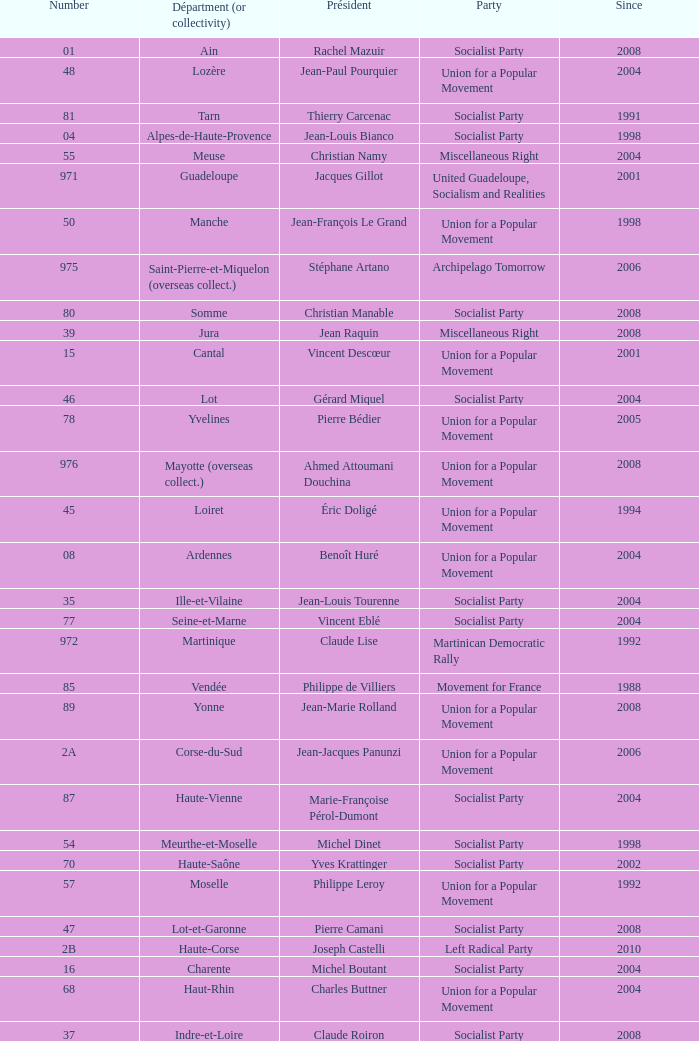Who is the president representing the Creuse department? Jean-Jacques Lozach. 